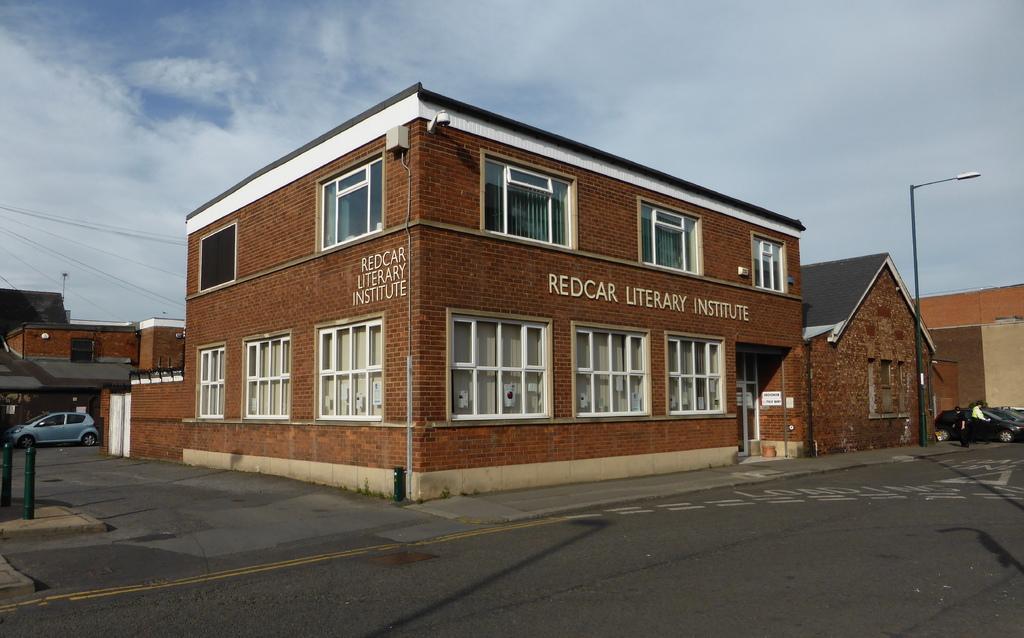Describe this image in one or two sentences. This is a building with the windows. I can see a street light. These are the people standing. On the left side of the image, I can see the buildings. These are the clouds in the sky. 